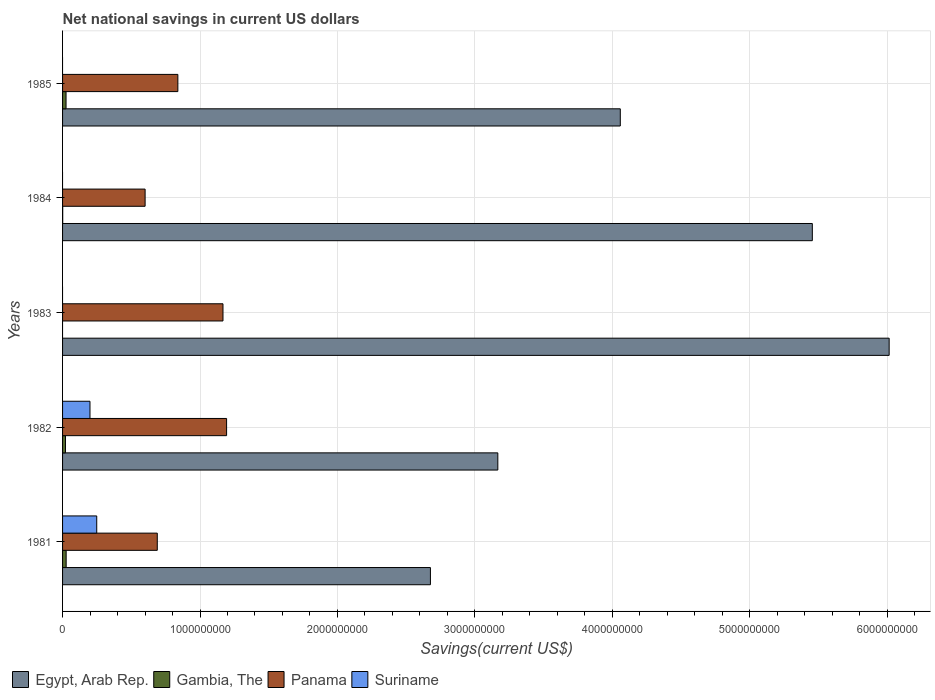Are the number of bars on each tick of the Y-axis equal?
Your answer should be compact. No. How many bars are there on the 1st tick from the top?
Provide a succinct answer. 3. In how many cases, is the number of bars for a given year not equal to the number of legend labels?
Offer a terse response. 3. What is the net national savings in Panama in 1985?
Offer a very short reply. 8.39e+08. Across all years, what is the maximum net national savings in Suriname?
Provide a short and direct response. 2.49e+08. Across all years, what is the minimum net national savings in Suriname?
Keep it short and to the point. 0. In which year was the net national savings in Egypt, Arab Rep. maximum?
Provide a succinct answer. 1983. What is the total net national savings in Gambia, The in the graph?
Give a very brief answer. 7.37e+07. What is the difference between the net national savings in Egypt, Arab Rep. in 1983 and that in 1985?
Your answer should be very brief. 1.96e+09. What is the difference between the net national savings in Egypt, Arab Rep. in 1981 and the net national savings in Gambia, The in 1984?
Give a very brief answer. 2.68e+09. What is the average net national savings in Panama per year?
Provide a short and direct response. 8.98e+08. In the year 1981, what is the difference between the net national savings in Egypt, Arab Rep. and net national savings in Panama?
Provide a short and direct response. 1.99e+09. What is the ratio of the net national savings in Panama in 1984 to that in 1985?
Offer a terse response. 0.72. Is the difference between the net national savings in Egypt, Arab Rep. in 1982 and 1985 greater than the difference between the net national savings in Panama in 1982 and 1985?
Provide a short and direct response. No. What is the difference between the highest and the second highest net national savings in Gambia, The?
Your answer should be very brief. 7.75e+05. What is the difference between the highest and the lowest net national savings in Suriname?
Ensure brevity in your answer.  2.49e+08. Is it the case that in every year, the sum of the net national savings in Egypt, Arab Rep. and net national savings in Gambia, The is greater than the sum of net national savings in Panama and net national savings in Suriname?
Provide a short and direct response. Yes. Is it the case that in every year, the sum of the net national savings in Panama and net national savings in Gambia, The is greater than the net national savings in Suriname?
Your answer should be compact. Yes. How many bars are there?
Your response must be concise. 16. Are the values on the major ticks of X-axis written in scientific E-notation?
Your answer should be very brief. No. Does the graph contain any zero values?
Ensure brevity in your answer.  Yes. Where does the legend appear in the graph?
Your answer should be very brief. Bottom left. How many legend labels are there?
Your response must be concise. 4. What is the title of the graph?
Your response must be concise. Net national savings in current US dollars. Does "Gabon" appear as one of the legend labels in the graph?
Keep it short and to the point. No. What is the label or title of the X-axis?
Provide a succinct answer. Savings(current US$). What is the Savings(current US$) of Egypt, Arab Rep. in 1981?
Offer a very short reply. 2.68e+09. What is the Savings(current US$) of Gambia, The in 1981?
Offer a very short reply. 2.61e+07. What is the Savings(current US$) in Panama in 1981?
Your answer should be compact. 6.89e+08. What is the Savings(current US$) in Suriname in 1981?
Your answer should be compact. 2.49e+08. What is the Savings(current US$) of Egypt, Arab Rep. in 1982?
Provide a short and direct response. 3.17e+09. What is the Savings(current US$) of Gambia, The in 1982?
Offer a terse response. 2.13e+07. What is the Savings(current US$) in Panama in 1982?
Provide a succinct answer. 1.19e+09. What is the Savings(current US$) in Suriname in 1982?
Make the answer very short. 1.99e+08. What is the Savings(current US$) of Egypt, Arab Rep. in 1983?
Provide a short and direct response. 6.01e+09. What is the Savings(current US$) of Gambia, The in 1983?
Keep it short and to the point. 0. What is the Savings(current US$) in Panama in 1983?
Keep it short and to the point. 1.17e+09. What is the Savings(current US$) of Suriname in 1983?
Give a very brief answer. 0. What is the Savings(current US$) in Egypt, Arab Rep. in 1984?
Your response must be concise. 5.46e+09. What is the Savings(current US$) in Gambia, The in 1984?
Make the answer very short. 9.54e+05. What is the Savings(current US$) in Panama in 1984?
Ensure brevity in your answer.  6.01e+08. What is the Savings(current US$) of Suriname in 1984?
Offer a very short reply. 0. What is the Savings(current US$) of Egypt, Arab Rep. in 1985?
Make the answer very short. 4.06e+09. What is the Savings(current US$) of Gambia, The in 1985?
Make the answer very short. 2.54e+07. What is the Savings(current US$) in Panama in 1985?
Offer a terse response. 8.39e+08. What is the Savings(current US$) of Suriname in 1985?
Give a very brief answer. 0. Across all years, what is the maximum Savings(current US$) of Egypt, Arab Rep.?
Give a very brief answer. 6.01e+09. Across all years, what is the maximum Savings(current US$) in Gambia, The?
Give a very brief answer. 2.61e+07. Across all years, what is the maximum Savings(current US$) of Panama?
Provide a short and direct response. 1.19e+09. Across all years, what is the maximum Savings(current US$) of Suriname?
Your response must be concise. 2.49e+08. Across all years, what is the minimum Savings(current US$) in Egypt, Arab Rep.?
Your response must be concise. 2.68e+09. Across all years, what is the minimum Savings(current US$) in Gambia, The?
Make the answer very short. 0. Across all years, what is the minimum Savings(current US$) in Panama?
Offer a very short reply. 6.01e+08. Across all years, what is the minimum Savings(current US$) of Suriname?
Provide a succinct answer. 0. What is the total Savings(current US$) in Egypt, Arab Rep. in the graph?
Offer a very short reply. 2.14e+1. What is the total Savings(current US$) in Gambia, The in the graph?
Your response must be concise. 7.37e+07. What is the total Savings(current US$) of Panama in the graph?
Keep it short and to the point. 4.49e+09. What is the total Savings(current US$) of Suriname in the graph?
Provide a succinct answer. 4.48e+08. What is the difference between the Savings(current US$) of Egypt, Arab Rep. in 1981 and that in 1982?
Offer a terse response. -4.90e+08. What is the difference between the Savings(current US$) of Gambia, The in 1981 and that in 1982?
Make the answer very short. 4.85e+06. What is the difference between the Savings(current US$) in Panama in 1981 and that in 1982?
Provide a short and direct response. -5.04e+08. What is the difference between the Savings(current US$) of Suriname in 1981 and that in 1982?
Make the answer very short. 4.91e+07. What is the difference between the Savings(current US$) in Egypt, Arab Rep. in 1981 and that in 1983?
Provide a short and direct response. -3.34e+09. What is the difference between the Savings(current US$) in Panama in 1981 and that in 1983?
Provide a succinct answer. -4.78e+08. What is the difference between the Savings(current US$) in Egypt, Arab Rep. in 1981 and that in 1984?
Offer a terse response. -2.78e+09. What is the difference between the Savings(current US$) in Gambia, The in 1981 and that in 1984?
Make the answer very short. 2.52e+07. What is the difference between the Savings(current US$) of Panama in 1981 and that in 1984?
Offer a very short reply. 8.86e+07. What is the difference between the Savings(current US$) of Egypt, Arab Rep. in 1981 and that in 1985?
Provide a short and direct response. -1.38e+09. What is the difference between the Savings(current US$) of Gambia, The in 1981 and that in 1985?
Give a very brief answer. 7.75e+05. What is the difference between the Savings(current US$) of Panama in 1981 and that in 1985?
Your answer should be compact. -1.50e+08. What is the difference between the Savings(current US$) of Egypt, Arab Rep. in 1982 and that in 1983?
Offer a terse response. -2.85e+09. What is the difference between the Savings(current US$) in Panama in 1982 and that in 1983?
Offer a very short reply. 2.63e+07. What is the difference between the Savings(current US$) of Egypt, Arab Rep. in 1982 and that in 1984?
Your answer should be compact. -2.29e+09. What is the difference between the Savings(current US$) in Gambia, The in 1982 and that in 1984?
Your answer should be compact. 2.03e+07. What is the difference between the Savings(current US$) in Panama in 1982 and that in 1984?
Give a very brief answer. 5.93e+08. What is the difference between the Savings(current US$) in Egypt, Arab Rep. in 1982 and that in 1985?
Provide a succinct answer. -8.91e+08. What is the difference between the Savings(current US$) in Gambia, The in 1982 and that in 1985?
Provide a short and direct response. -4.08e+06. What is the difference between the Savings(current US$) of Panama in 1982 and that in 1985?
Your answer should be very brief. 3.55e+08. What is the difference between the Savings(current US$) in Egypt, Arab Rep. in 1983 and that in 1984?
Your answer should be compact. 5.59e+08. What is the difference between the Savings(current US$) of Panama in 1983 and that in 1984?
Provide a short and direct response. 5.67e+08. What is the difference between the Savings(current US$) in Egypt, Arab Rep. in 1983 and that in 1985?
Your answer should be very brief. 1.96e+09. What is the difference between the Savings(current US$) of Panama in 1983 and that in 1985?
Your answer should be compact. 3.28e+08. What is the difference between the Savings(current US$) in Egypt, Arab Rep. in 1984 and that in 1985?
Provide a succinct answer. 1.40e+09. What is the difference between the Savings(current US$) in Gambia, The in 1984 and that in 1985?
Make the answer very short. -2.44e+07. What is the difference between the Savings(current US$) in Panama in 1984 and that in 1985?
Ensure brevity in your answer.  -2.38e+08. What is the difference between the Savings(current US$) in Egypt, Arab Rep. in 1981 and the Savings(current US$) in Gambia, The in 1982?
Make the answer very short. 2.66e+09. What is the difference between the Savings(current US$) of Egypt, Arab Rep. in 1981 and the Savings(current US$) of Panama in 1982?
Offer a very short reply. 1.48e+09. What is the difference between the Savings(current US$) in Egypt, Arab Rep. in 1981 and the Savings(current US$) in Suriname in 1982?
Provide a short and direct response. 2.48e+09. What is the difference between the Savings(current US$) in Gambia, The in 1981 and the Savings(current US$) in Panama in 1982?
Ensure brevity in your answer.  -1.17e+09. What is the difference between the Savings(current US$) of Gambia, The in 1981 and the Savings(current US$) of Suriname in 1982?
Provide a short and direct response. -1.73e+08. What is the difference between the Savings(current US$) of Panama in 1981 and the Savings(current US$) of Suriname in 1982?
Make the answer very short. 4.90e+08. What is the difference between the Savings(current US$) of Egypt, Arab Rep. in 1981 and the Savings(current US$) of Panama in 1983?
Provide a short and direct response. 1.51e+09. What is the difference between the Savings(current US$) in Gambia, The in 1981 and the Savings(current US$) in Panama in 1983?
Provide a short and direct response. -1.14e+09. What is the difference between the Savings(current US$) in Egypt, Arab Rep. in 1981 and the Savings(current US$) in Gambia, The in 1984?
Give a very brief answer. 2.68e+09. What is the difference between the Savings(current US$) of Egypt, Arab Rep. in 1981 and the Savings(current US$) of Panama in 1984?
Keep it short and to the point. 2.08e+09. What is the difference between the Savings(current US$) of Gambia, The in 1981 and the Savings(current US$) of Panama in 1984?
Keep it short and to the point. -5.74e+08. What is the difference between the Savings(current US$) of Egypt, Arab Rep. in 1981 and the Savings(current US$) of Gambia, The in 1985?
Offer a very short reply. 2.65e+09. What is the difference between the Savings(current US$) of Egypt, Arab Rep. in 1981 and the Savings(current US$) of Panama in 1985?
Your answer should be very brief. 1.84e+09. What is the difference between the Savings(current US$) in Gambia, The in 1981 and the Savings(current US$) in Panama in 1985?
Your response must be concise. -8.13e+08. What is the difference between the Savings(current US$) of Egypt, Arab Rep. in 1982 and the Savings(current US$) of Panama in 1983?
Give a very brief answer. 2.00e+09. What is the difference between the Savings(current US$) in Gambia, The in 1982 and the Savings(current US$) in Panama in 1983?
Keep it short and to the point. -1.15e+09. What is the difference between the Savings(current US$) of Egypt, Arab Rep. in 1982 and the Savings(current US$) of Gambia, The in 1984?
Keep it short and to the point. 3.17e+09. What is the difference between the Savings(current US$) in Egypt, Arab Rep. in 1982 and the Savings(current US$) in Panama in 1984?
Offer a terse response. 2.57e+09. What is the difference between the Savings(current US$) in Gambia, The in 1982 and the Savings(current US$) in Panama in 1984?
Your response must be concise. -5.79e+08. What is the difference between the Savings(current US$) of Egypt, Arab Rep. in 1982 and the Savings(current US$) of Gambia, The in 1985?
Ensure brevity in your answer.  3.14e+09. What is the difference between the Savings(current US$) in Egypt, Arab Rep. in 1982 and the Savings(current US$) in Panama in 1985?
Make the answer very short. 2.33e+09. What is the difference between the Savings(current US$) of Gambia, The in 1982 and the Savings(current US$) of Panama in 1985?
Your response must be concise. -8.18e+08. What is the difference between the Savings(current US$) of Egypt, Arab Rep. in 1983 and the Savings(current US$) of Gambia, The in 1984?
Your answer should be compact. 6.01e+09. What is the difference between the Savings(current US$) of Egypt, Arab Rep. in 1983 and the Savings(current US$) of Panama in 1984?
Give a very brief answer. 5.41e+09. What is the difference between the Savings(current US$) in Egypt, Arab Rep. in 1983 and the Savings(current US$) in Gambia, The in 1985?
Make the answer very short. 5.99e+09. What is the difference between the Savings(current US$) of Egypt, Arab Rep. in 1983 and the Savings(current US$) of Panama in 1985?
Your response must be concise. 5.18e+09. What is the difference between the Savings(current US$) of Egypt, Arab Rep. in 1984 and the Savings(current US$) of Gambia, The in 1985?
Offer a terse response. 5.43e+09. What is the difference between the Savings(current US$) in Egypt, Arab Rep. in 1984 and the Savings(current US$) in Panama in 1985?
Offer a very short reply. 4.62e+09. What is the difference between the Savings(current US$) of Gambia, The in 1984 and the Savings(current US$) of Panama in 1985?
Your answer should be very brief. -8.38e+08. What is the average Savings(current US$) of Egypt, Arab Rep. per year?
Provide a succinct answer. 4.27e+09. What is the average Savings(current US$) in Gambia, The per year?
Keep it short and to the point. 1.47e+07. What is the average Savings(current US$) of Panama per year?
Your answer should be very brief. 8.98e+08. What is the average Savings(current US$) of Suriname per year?
Provide a short and direct response. 8.96e+07. In the year 1981, what is the difference between the Savings(current US$) in Egypt, Arab Rep. and Savings(current US$) in Gambia, The?
Offer a terse response. 2.65e+09. In the year 1981, what is the difference between the Savings(current US$) in Egypt, Arab Rep. and Savings(current US$) in Panama?
Offer a very short reply. 1.99e+09. In the year 1981, what is the difference between the Savings(current US$) in Egypt, Arab Rep. and Savings(current US$) in Suriname?
Give a very brief answer. 2.43e+09. In the year 1981, what is the difference between the Savings(current US$) of Gambia, The and Savings(current US$) of Panama?
Provide a succinct answer. -6.63e+08. In the year 1981, what is the difference between the Savings(current US$) of Gambia, The and Savings(current US$) of Suriname?
Your answer should be very brief. -2.22e+08. In the year 1981, what is the difference between the Savings(current US$) in Panama and Savings(current US$) in Suriname?
Your response must be concise. 4.41e+08. In the year 1982, what is the difference between the Savings(current US$) of Egypt, Arab Rep. and Savings(current US$) of Gambia, The?
Give a very brief answer. 3.15e+09. In the year 1982, what is the difference between the Savings(current US$) of Egypt, Arab Rep. and Savings(current US$) of Panama?
Provide a succinct answer. 1.97e+09. In the year 1982, what is the difference between the Savings(current US$) of Egypt, Arab Rep. and Savings(current US$) of Suriname?
Ensure brevity in your answer.  2.97e+09. In the year 1982, what is the difference between the Savings(current US$) of Gambia, The and Savings(current US$) of Panama?
Your response must be concise. -1.17e+09. In the year 1982, what is the difference between the Savings(current US$) in Gambia, The and Savings(current US$) in Suriname?
Offer a terse response. -1.78e+08. In the year 1982, what is the difference between the Savings(current US$) of Panama and Savings(current US$) of Suriname?
Make the answer very short. 9.94e+08. In the year 1983, what is the difference between the Savings(current US$) in Egypt, Arab Rep. and Savings(current US$) in Panama?
Give a very brief answer. 4.85e+09. In the year 1984, what is the difference between the Savings(current US$) of Egypt, Arab Rep. and Savings(current US$) of Gambia, The?
Make the answer very short. 5.45e+09. In the year 1984, what is the difference between the Savings(current US$) in Egypt, Arab Rep. and Savings(current US$) in Panama?
Offer a very short reply. 4.85e+09. In the year 1984, what is the difference between the Savings(current US$) in Gambia, The and Savings(current US$) in Panama?
Offer a very short reply. -6.00e+08. In the year 1985, what is the difference between the Savings(current US$) of Egypt, Arab Rep. and Savings(current US$) of Gambia, The?
Provide a succinct answer. 4.03e+09. In the year 1985, what is the difference between the Savings(current US$) in Egypt, Arab Rep. and Savings(current US$) in Panama?
Keep it short and to the point. 3.22e+09. In the year 1985, what is the difference between the Savings(current US$) in Gambia, The and Savings(current US$) in Panama?
Provide a succinct answer. -8.14e+08. What is the ratio of the Savings(current US$) in Egypt, Arab Rep. in 1981 to that in 1982?
Your answer should be very brief. 0.85. What is the ratio of the Savings(current US$) of Gambia, The in 1981 to that in 1982?
Provide a short and direct response. 1.23. What is the ratio of the Savings(current US$) of Panama in 1981 to that in 1982?
Offer a very short reply. 0.58. What is the ratio of the Savings(current US$) in Suriname in 1981 to that in 1982?
Provide a short and direct response. 1.25. What is the ratio of the Savings(current US$) in Egypt, Arab Rep. in 1981 to that in 1983?
Offer a very short reply. 0.45. What is the ratio of the Savings(current US$) of Panama in 1981 to that in 1983?
Provide a short and direct response. 0.59. What is the ratio of the Savings(current US$) in Egypt, Arab Rep. in 1981 to that in 1984?
Offer a terse response. 0.49. What is the ratio of the Savings(current US$) in Gambia, The in 1981 to that in 1984?
Offer a terse response. 27.38. What is the ratio of the Savings(current US$) in Panama in 1981 to that in 1984?
Give a very brief answer. 1.15. What is the ratio of the Savings(current US$) of Egypt, Arab Rep. in 1981 to that in 1985?
Offer a very short reply. 0.66. What is the ratio of the Savings(current US$) in Gambia, The in 1981 to that in 1985?
Provide a succinct answer. 1.03. What is the ratio of the Savings(current US$) in Panama in 1981 to that in 1985?
Your answer should be very brief. 0.82. What is the ratio of the Savings(current US$) of Egypt, Arab Rep. in 1982 to that in 1983?
Keep it short and to the point. 0.53. What is the ratio of the Savings(current US$) in Panama in 1982 to that in 1983?
Keep it short and to the point. 1.02. What is the ratio of the Savings(current US$) of Egypt, Arab Rep. in 1982 to that in 1984?
Your response must be concise. 0.58. What is the ratio of the Savings(current US$) of Gambia, The in 1982 to that in 1984?
Give a very brief answer. 22.29. What is the ratio of the Savings(current US$) of Panama in 1982 to that in 1984?
Keep it short and to the point. 1.99. What is the ratio of the Savings(current US$) in Egypt, Arab Rep. in 1982 to that in 1985?
Your response must be concise. 0.78. What is the ratio of the Savings(current US$) of Gambia, The in 1982 to that in 1985?
Offer a terse response. 0.84. What is the ratio of the Savings(current US$) of Panama in 1982 to that in 1985?
Your answer should be compact. 1.42. What is the ratio of the Savings(current US$) in Egypt, Arab Rep. in 1983 to that in 1984?
Offer a very short reply. 1.1. What is the ratio of the Savings(current US$) of Panama in 1983 to that in 1984?
Keep it short and to the point. 1.94. What is the ratio of the Savings(current US$) in Egypt, Arab Rep. in 1983 to that in 1985?
Keep it short and to the point. 1.48. What is the ratio of the Savings(current US$) of Panama in 1983 to that in 1985?
Your answer should be very brief. 1.39. What is the ratio of the Savings(current US$) of Egypt, Arab Rep. in 1984 to that in 1985?
Your answer should be compact. 1.34. What is the ratio of the Savings(current US$) of Gambia, The in 1984 to that in 1985?
Provide a short and direct response. 0.04. What is the ratio of the Savings(current US$) in Panama in 1984 to that in 1985?
Make the answer very short. 0.72. What is the difference between the highest and the second highest Savings(current US$) in Egypt, Arab Rep.?
Provide a succinct answer. 5.59e+08. What is the difference between the highest and the second highest Savings(current US$) in Gambia, The?
Provide a short and direct response. 7.75e+05. What is the difference between the highest and the second highest Savings(current US$) of Panama?
Ensure brevity in your answer.  2.63e+07. What is the difference between the highest and the lowest Savings(current US$) in Egypt, Arab Rep.?
Provide a short and direct response. 3.34e+09. What is the difference between the highest and the lowest Savings(current US$) in Gambia, The?
Offer a terse response. 2.61e+07. What is the difference between the highest and the lowest Savings(current US$) in Panama?
Your response must be concise. 5.93e+08. What is the difference between the highest and the lowest Savings(current US$) in Suriname?
Offer a terse response. 2.49e+08. 